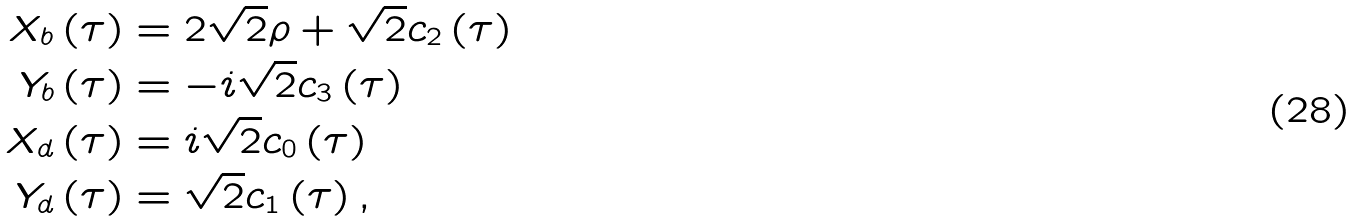<formula> <loc_0><loc_0><loc_500><loc_500>X _ { b } \left ( \tau \right ) & = 2 \sqrt { 2 } \rho + \sqrt { 2 } c _ { 2 } \left ( \tau \right ) \\ Y _ { b } \left ( \tau \right ) & = - i \sqrt { 2 } c _ { 3 } \left ( \tau \right ) \\ X _ { d } \left ( \tau \right ) & = i \sqrt { 2 } c _ { 0 } \left ( \tau \right ) \\ Y _ { d } \left ( \tau \right ) & = \sqrt { 2 } c _ { 1 } \left ( \tau \right ) ,</formula> 